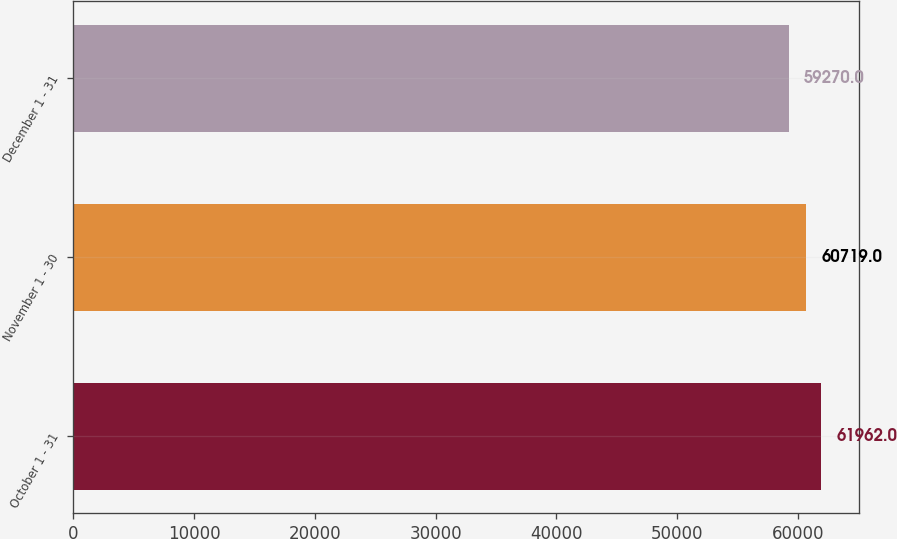Convert chart to OTSL. <chart><loc_0><loc_0><loc_500><loc_500><bar_chart><fcel>October 1 - 31<fcel>November 1 - 30<fcel>December 1 - 31<nl><fcel>61962<fcel>60719<fcel>59270<nl></chart> 